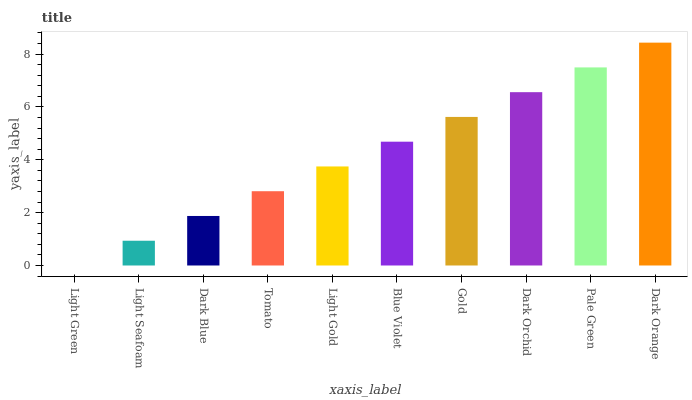Is Light Seafoam the minimum?
Answer yes or no. No. Is Light Seafoam the maximum?
Answer yes or no. No. Is Light Seafoam greater than Light Green?
Answer yes or no. Yes. Is Light Green less than Light Seafoam?
Answer yes or no. Yes. Is Light Green greater than Light Seafoam?
Answer yes or no. No. Is Light Seafoam less than Light Green?
Answer yes or no. No. Is Blue Violet the high median?
Answer yes or no. Yes. Is Light Gold the low median?
Answer yes or no. Yes. Is Tomato the high median?
Answer yes or no. No. Is Dark Blue the low median?
Answer yes or no. No. 